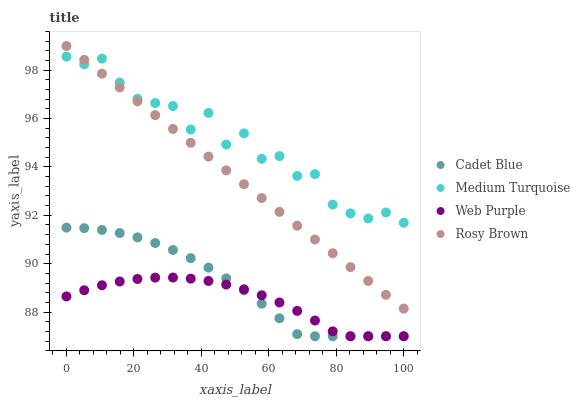Does Web Purple have the minimum area under the curve?
Answer yes or no. Yes. Does Medium Turquoise have the maximum area under the curve?
Answer yes or no. Yes. Does Cadet Blue have the minimum area under the curve?
Answer yes or no. No. Does Cadet Blue have the maximum area under the curve?
Answer yes or no. No. Is Rosy Brown the smoothest?
Answer yes or no. Yes. Is Medium Turquoise the roughest?
Answer yes or no. Yes. Is Cadet Blue the smoothest?
Answer yes or no. No. Is Cadet Blue the roughest?
Answer yes or no. No. Does Web Purple have the lowest value?
Answer yes or no. Yes. Does Rosy Brown have the lowest value?
Answer yes or no. No. Does Rosy Brown have the highest value?
Answer yes or no. Yes. Does Cadet Blue have the highest value?
Answer yes or no. No. Is Web Purple less than Rosy Brown?
Answer yes or no. Yes. Is Rosy Brown greater than Cadet Blue?
Answer yes or no. Yes. Does Rosy Brown intersect Medium Turquoise?
Answer yes or no. Yes. Is Rosy Brown less than Medium Turquoise?
Answer yes or no. No. Is Rosy Brown greater than Medium Turquoise?
Answer yes or no. No. Does Web Purple intersect Rosy Brown?
Answer yes or no. No. 